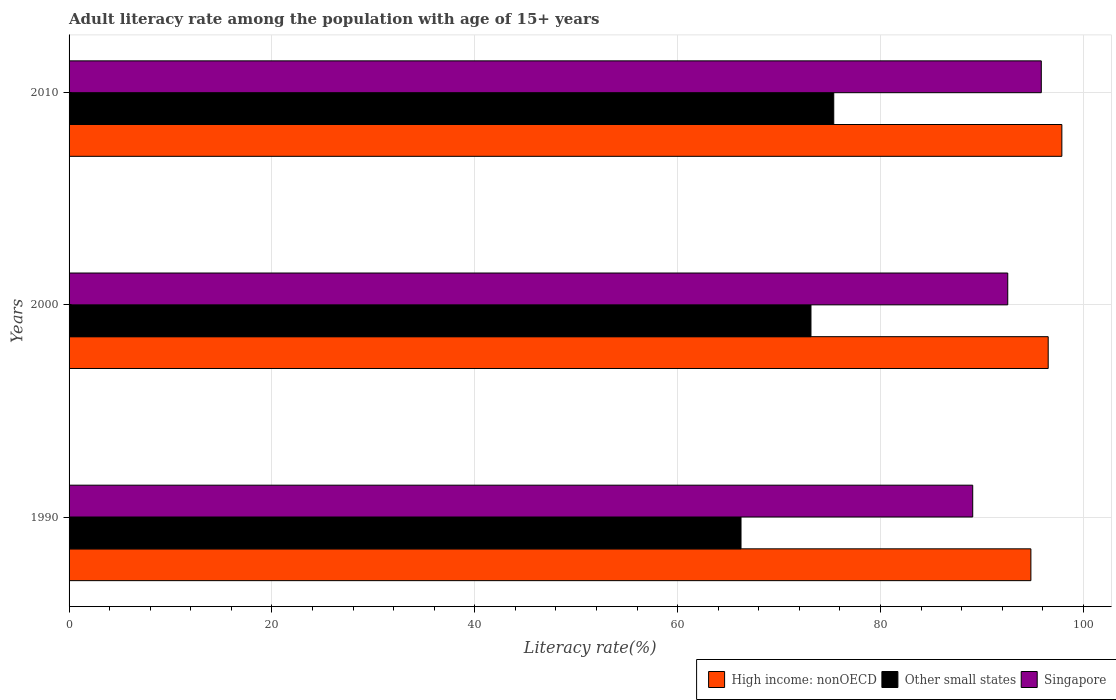Are the number of bars per tick equal to the number of legend labels?
Your answer should be compact. Yes. How many bars are there on the 1st tick from the bottom?
Ensure brevity in your answer.  3. What is the label of the 2nd group of bars from the top?
Keep it short and to the point. 2000. What is the adult literacy rate in Singapore in 2000?
Provide a succinct answer. 92.55. Across all years, what is the maximum adult literacy rate in Singapore?
Your answer should be very brief. 95.86. Across all years, what is the minimum adult literacy rate in Singapore?
Ensure brevity in your answer.  89.1. In which year was the adult literacy rate in Singapore maximum?
Your answer should be compact. 2010. What is the total adult literacy rate in Other small states in the graph?
Ensure brevity in your answer.  214.79. What is the difference between the adult literacy rate in Singapore in 1990 and that in 2000?
Make the answer very short. -3.45. What is the difference between the adult literacy rate in High income: nonOECD in 1990 and the adult literacy rate in Other small states in 2000?
Your response must be concise. 21.68. What is the average adult literacy rate in High income: nonOECD per year?
Provide a succinct answer. 96.42. In the year 2010, what is the difference between the adult literacy rate in High income: nonOECD and adult literacy rate in Singapore?
Ensure brevity in your answer.  2.03. What is the ratio of the adult literacy rate in Singapore in 1990 to that in 2010?
Ensure brevity in your answer.  0.93. Is the adult literacy rate in Singapore in 2000 less than that in 2010?
Offer a terse response. Yes. What is the difference between the highest and the second highest adult literacy rate in Other small states?
Your response must be concise. 2.25. What is the difference between the highest and the lowest adult literacy rate in High income: nonOECD?
Keep it short and to the point. 3.05. What does the 3rd bar from the top in 2010 represents?
Give a very brief answer. High income: nonOECD. What does the 3rd bar from the bottom in 2010 represents?
Provide a short and direct response. Singapore. How many bars are there?
Ensure brevity in your answer.  9. Are all the bars in the graph horizontal?
Offer a terse response. Yes. Does the graph contain grids?
Make the answer very short. Yes. How are the legend labels stacked?
Keep it short and to the point. Horizontal. What is the title of the graph?
Your answer should be very brief. Adult literacy rate among the population with age of 15+ years. Does "Senegal" appear as one of the legend labels in the graph?
Your answer should be compact. No. What is the label or title of the X-axis?
Ensure brevity in your answer.  Literacy rate(%). What is the label or title of the Y-axis?
Keep it short and to the point. Years. What is the Literacy rate(%) of High income: nonOECD in 1990?
Offer a terse response. 94.83. What is the Literacy rate(%) of Other small states in 1990?
Your answer should be compact. 66.25. What is the Literacy rate(%) of Singapore in 1990?
Your answer should be very brief. 89.1. What is the Literacy rate(%) of High income: nonOECD in 2000?
Offer a terse response. 96.54. What is the Literacy rate(%) in Other small states in 2000?
Your answer should be very brief. 73.15. What is the Literacy rate(%) in Singapore in 2000?
Offer a terse response. 92.55. What is the Literacy rate(%) in High income: nonOECD in 2010?
Make the answer very short. 97.88. What is the Literacy rate(%) in Other small states in 2010?
Your answer should be compact. 75.39. What is the Literacy rate(%) in Singapore in 2010?
Offer a terse response. 95.86. Across all years, what is the maximum Literacy rate(%) of High income: nonOECD?
Ensure brevity in your answer.  97.88. Across all years, what is the maximum Literacy rate(%) in Other small states?
Offer a terse response. 75.39. Across all years, what is the maximum Literacy rate(%) in Singapore?
Your response must be concise. 95.86. Across all years, what is the minimum Literacy rate(%) of High income: nonOECD?
Offer a terse response. 94.83. Across all years, what is the minimum Literacy rate(%) in Other small states?
Offer a terse response. 66.25. Across all years, what is the minimum Literacy rate(%) of Singapore?
Give a very brief answer. 89.1. What is the total Literacy rate(%) in High income: nonOECD in the graph?
Provide a short and direct response. 289.25. What is the total Literacy rate(%) of Other small states in the graph?
Keep it short and to the point. 214.79. What is the total Literacy rate(%) of Singapore in the graph?
Offer a very short reply. 277.5. What is the difference between the Literacy rate(%) in High income: nonOECD in 1990 and that in 2000?
Your answer should be very brief. -1.71. What is the difference between the Literacy rate(%) of Other small states in 1990 and that in 2000?
Your answer should be compact. -6.9. What is the difference between the Literacy rate(%) in Singapore in 1990 and that in 2000?
Make the answer very short. -3.45. What is the difference between the Literacy rate(%) of High income: nonOECD in 1990 and that in 2010?
Your response must be concise. -3.05. What is the difference between the Literacy rate(%) in Other small states in 1990 and that in 2010?
Ensure brevity in your answer.  -9.14. What is the difference between the Literacy rate(%) in Singapore in 1990 and that in 2010?
Offer a terse response. -6.76. What is the difference between the Literacy rate(%) in High income: nonOECD in 2000 and that in 2010?
Offer a very short reply. -1.35. What is the difference between the Literacy rate(%) of Other small states in 2000 and that in 2010?
Offer a terse response. -2.25. What is the difference between the Literacy rate(%) in Singapore in 2000 and that in 2010?
Give a very brief answer. -3.31. What is the difference between the Literacy rate(%) in High income: nonOECD in 1990 and the Literacy rate(%) in Other small states in 2000?
Keep it short and to the point. 21.68. What is the difference between the Literacy rate(%) of High income: nonOECD in 1990 and the Literacy rate(%) of Singapore in 2000?
Keep it short and to the point. 2.28. What is the difference between the Literacy rate(%) in Other small states in 1990 and the Literacy rate(%) in Singapore in 2000?
Give a very brief answer. -26.3. What is the difference between the Literacy rate(%) in High income: nonOECD in 1990 and the Literacy rate(%) in Other small states in 2010?
Give a very brief answer. 19.44. What is the difference between the Literacy rate(%) in High income: nonOECD in 1990 and the Literacy rate(%) in Singapore in 2010?
Offer a very short reply. -1.03. What is the difference between the Literacy rate(%) of Other small states in 1990 and the Literacy rate(%) of Singapore in 2010?
Make the answer very short. -29.61. What is the difference between the Literacy rate(%) in High income: nonOECD in 2000 and the Literacy rate(%) in Other small states in 2010?
Ensure brevity in your answer.  21.14. What is the difference between the Literacy rate(%) in High income: nonOECD in 2000 and the Literacy rate(%) in Singapore in 2010?
Your answer should be very brief. 0.68. What is the difference between the Literacy rate(%) in Other small states in 2000 and the Literacy rate(%) in Singapore in 2010?
Your response must be concise. -22.71. What is the average Literacy rate(%) in High income: nonOECD per year?
Provide a short and direct response. 96.42. What is the average Literacy rate(%) of Other small states per year?
Provide a succinct answer. 71.6. What is the average Literacy rate(%) of Singapore per year?
Make the answer very short. 92.5. In the year 1990, what is the difference between the Literacy rate(%) in High income: nonOECD and Literacy rate(%) in Other small states?
Make the answer very short. 28.58. In the year 1990, what is the difference between the Literacy rate(%) in High income: nonOECD and Literacy rate(%) in Singapore?
Your answer should be very brief. 5.74. In the year 1990, what is the difference between the Literacy rate(%) in Other small states and Literacy rate(%) in Singapore?
Provide a short and direct response. -22.85. In the year 2000, what is the difference between the Literacy rate(%) of High income: nonOECD and Literacy rate(%) of Other small states?
Offer a very short reply. 23.39. In the year 2000, what is the difference between the Literacy rate(%) of High income: nonOECD and Literacy rate(%) of Singapore?
Your response must be concise. 3.99. In the year 2000, what is the difference between the Literacy rate(%) of Other small states and Literacy rate(%) of Singapore?
Ensure brevity in your answer.  -19.4. In the year 2010, what is the difference between the Literacy rate(%) of High income: nonOECD and Literacy rate(%) of Other small states?
Keep it short and to the point. 22.49. In the year 2010, what is the difference between the Literacy rate(%) of High income: nonOECD and Literacy rate(%) of Singapore?
Your response must be concise. 2.03. In the year 2010, what is the difference between the Literacy rate(%) in Other small states and Literacy rate(%) in Singapore?
Keep it short and to the point. -20.46. What is the ratio of the Literacy rate(%) in High income: nonOECD in 1990 to that in 2000?
Offer a terse response. 0.98. What is the ratio of the Literacy rate(%) in Other small states in 1990 to that in 2000?
Provide a short and direct response. 0.91. What is the ratio of the Literacy rate(%) in Singapore in 1990 to that in 2000?
Make the answer very short. 0.96. What is the ratio of the Literacy rate(%) of High income: nonOECD in 1990 to that in 2010?
Provide a succinct answer. 0.97. What is the ratio of the Literacy rate(%) in Other small states in 1990 to that in 2010?
Ensure brevity in your answer.  0.88. What is the ratio of the Literacy rate(%) of Singapore in 1990 to that in 2010?
Provide a succinct answer. 0.93. What is the ratio of the Literacy rate(%) in High income: nonOECD in 2000 to that in 2010?
Keep it short and to the point. 0.99. What is the ratio of the Literacy rate(%) in Other small states in 2000 to that in 2010?
Keep it short and to the point. 0.97. What is the ratio of the Literacy rate(%) in Singapore in 2000 to that in 2010?
Ensure brevity in your answer.  0.97. What is the difference between the highest and the second highest Literacy rate(%) of High income: nonOECD?
Provide a short and direct response. 1.35. What is the difference between the highest and the second highest Literacy rate(%) of Other small states?
Offer a very short reply. 2.25. What is the difference between the highest and the second highest Literacy rate(%) in Singapore?
Ensure brevity in your answer.  3.31. What is the difference between the highest and the lowest Literacy rate(%) in High income: nonOECD?
Provide a succinct answer. 3.05. What is the difference between the highest and the lowest Literacy rate(%) in Other small states?
Ensure brevity in your answer.  9.14. What is the difference between the highest and the lowest Literacy rate(%) in Singapore?
Your answer should be compact. 6.76. 